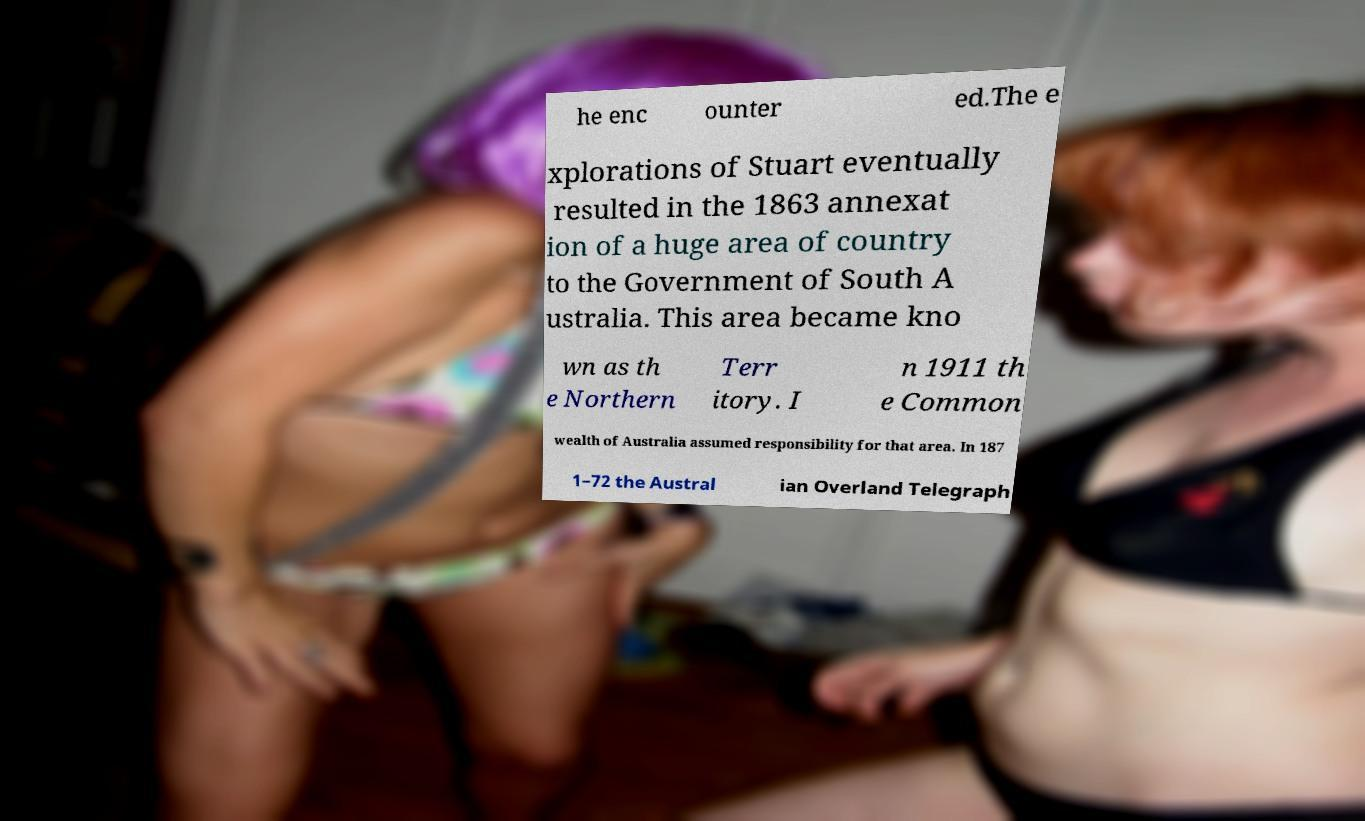There's text embedded in this image that I need extracted. Can you transcribe it verbatim? he enc ounter ed.The e xplorations of Stuart eventually resulted in the 1863 annexat ion of a huge area of country to the Government of South A ustralia. This area became kno wn as th e Northern Terr itory. I n 1911 th e Common wealth of Australia assumed responsibility for that area. In 187 1–72 the Austral ian Overland Telegraph 